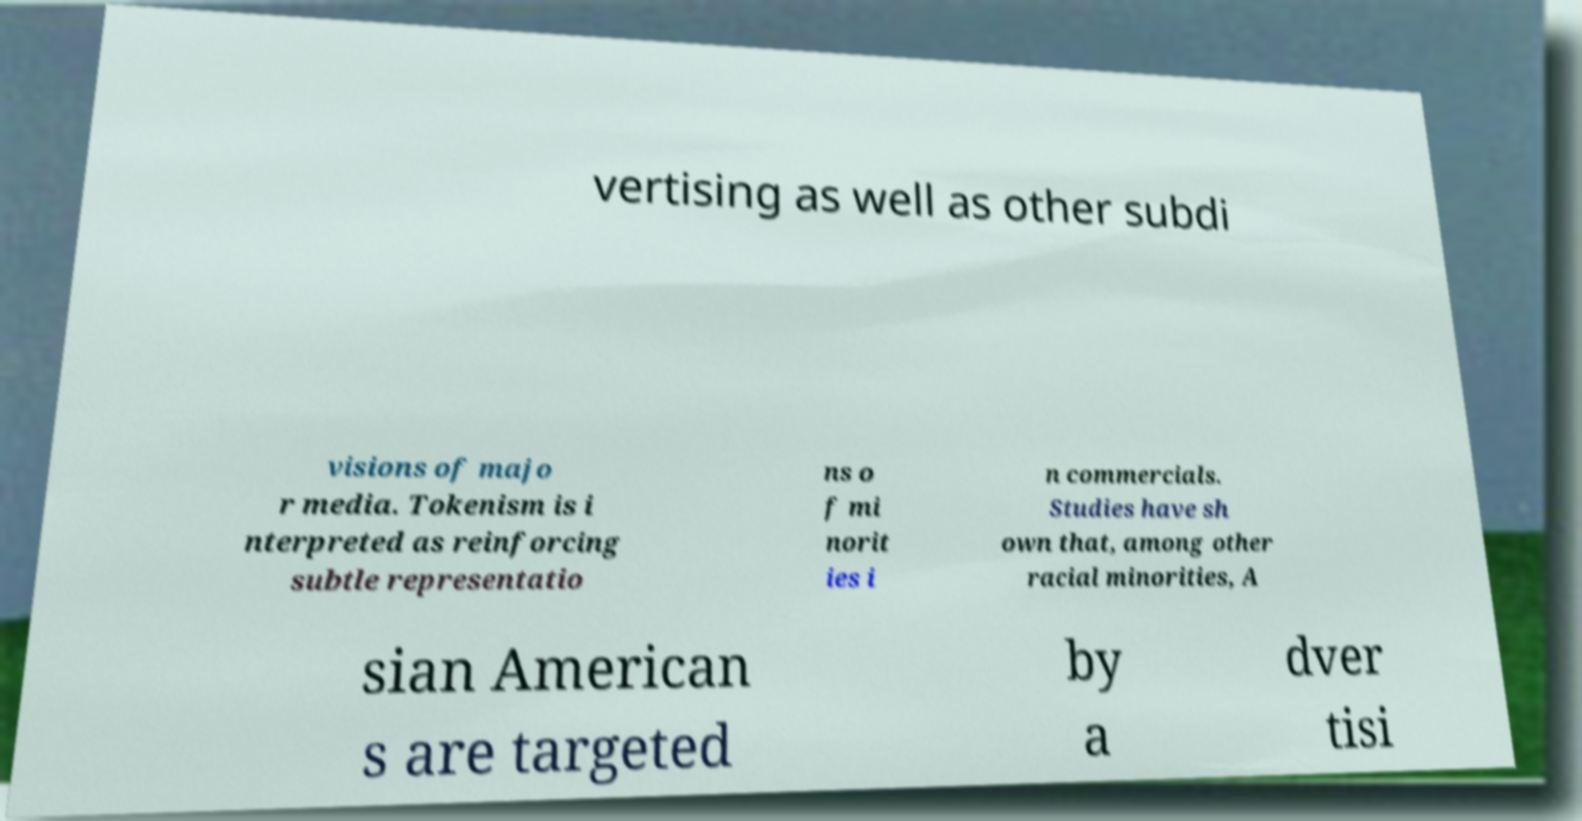Can you explain the significance of 'tokenism' as mentioned in the image text? Tokenism in this context refers to the practice of making only a perfunctory or symbolic effort to include minorities in advertising. It's often criticized for being superficial and not providing genuine representation or equal opportunities. 